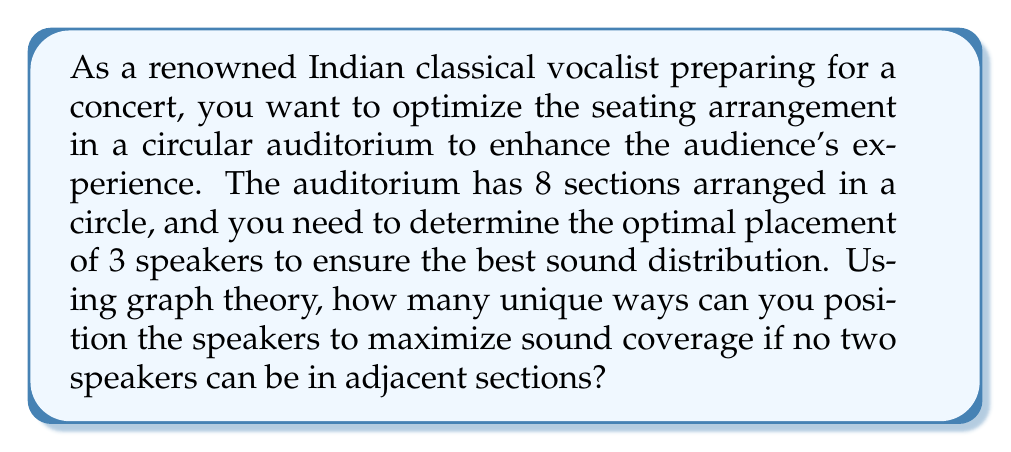Show me your answer to this math problem. To solve this problem, we can use graph theory concepts, specifically the independence number of a cycle graph. Let's approach this step-by-step:

1) First, we can model the auditorium as a cycle graph $C_8$, where each vertex represents a section, and edges represent adjacency between sections.

2) The problem of placing speakers in non-adjacent sections is equivalent to finding an independent set in the graph. An independent set is a set of vertices in a graph, no two of which are adjacent.

3) We are looking for independent sets of size 3 in $C_8$. This is related to the concept of independence number $\alpha(G)$, which is the size of the largest independent set in a graph G.

4) For a cycle graph $C_n$, the independence number is given by:

   $$\alpha(C_n) = \lfloor \frac{n}{2} \rfloor$$

   In our case, $\alpha(C_8) = \lfloor \frac{8}{2} \rfloor = 4$

5) To count the number of ways to choose 3 non-adjacent vertices in $C_8$, we can use the concept of circular permutations with restrictions.

6) We can start by placing the first speaker in any of the 8 sections. Due to rotational symmetry, we can fix this first position.

7) For the second speaker, we have 5 valid positions (skipping the adjacent sections).

8) For the third speaker, we have 3 valid positions (skipping the adjacent sections to both placed speakers).

9) Therefore, the total number of unique arrangements is:

   $$1 \times 5 \times 3 = 15$$

This result represents the number of unique ways to position 3 speakers in non-adjacent sections of the 8-section circular auditorium.
Answer: 15 unique arrangements 